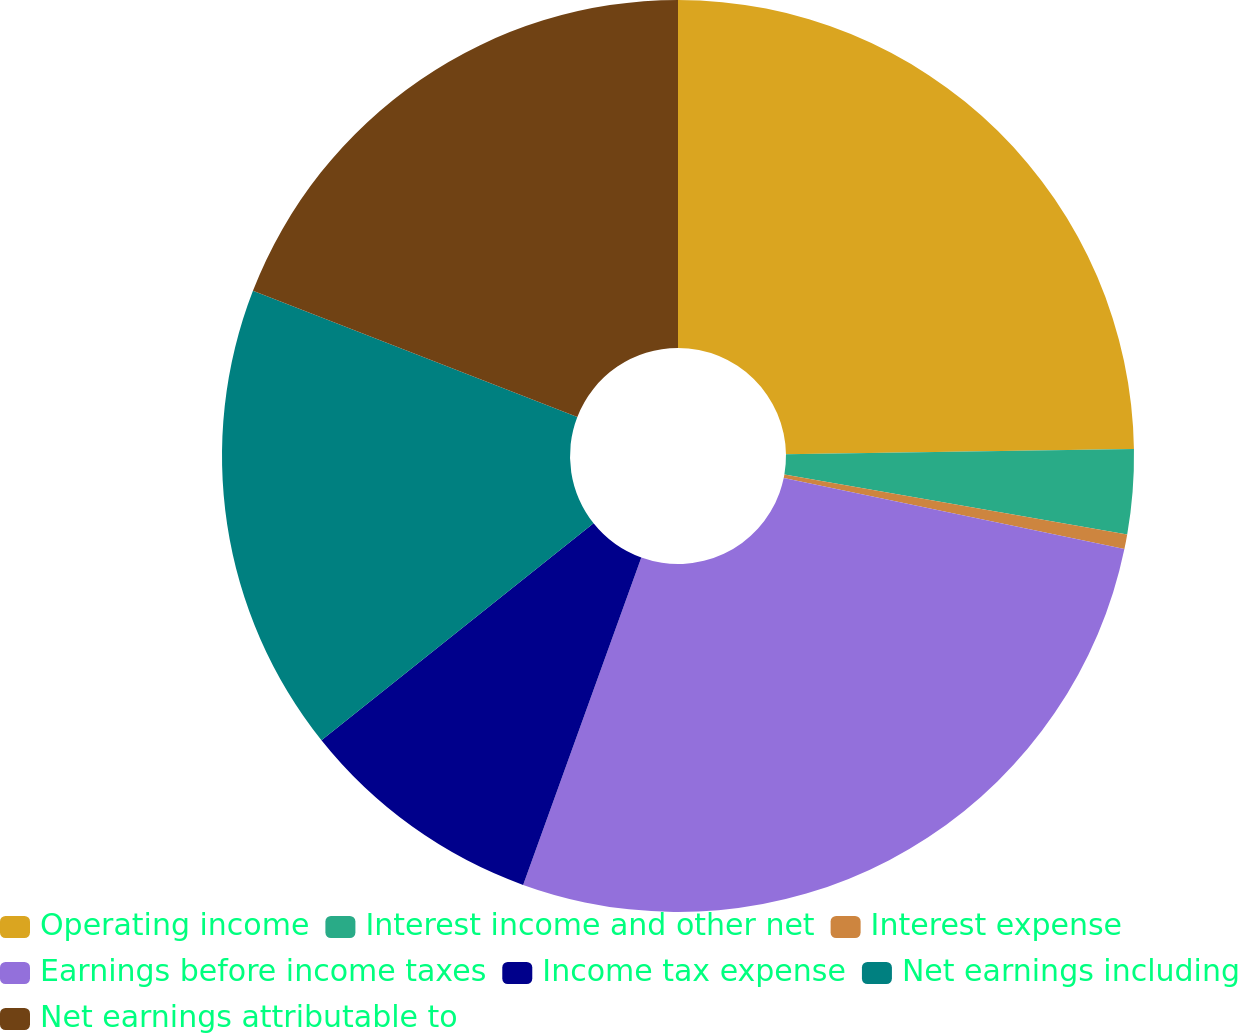Convert chart. <chart><loc_0><loc_0><loc_500><loc_500><pie_chart><fcel>Operating income<fcel>Interest income and other net<fcel>Interest expense<fcel>Earnings before income taxes<fcel>Income tax expense<fcel>Net earnings including<fcel>Net earnings attributable to<nl><fcel>24.75%<fcel>3.0%<fcel>0.52%<fcel>27.24%<fcel>8.77%<fcel>16.61%<fcel>19.1%<nl></chart> 